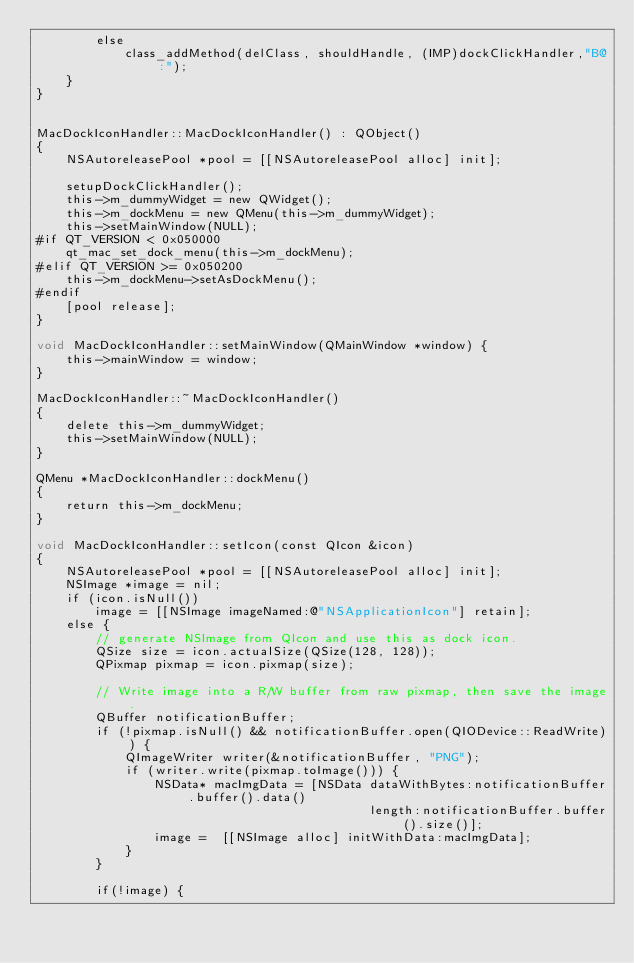Convert code to text. <code><loc_0><loc_0><loc_500><loc_500><_ObjectiveC_>        else
            class_addMethod(delClass, shouldHandle, (IMP)dockClickHandler,"B@:");
    }
}


MacDockIconHandler::MacDockIconHandler() : QObject()
{
    NSAutoreleasePool *pool = [[NSAutoreleasePool alloc] init];

    setupDockClickHandler();
    this->m_dummyWidget = new QWidget();
    this->m_dockMenu = new QMenu(this->m_dummyWidget);
    this->setMainWindow(NULL);
#if QT_VERSION < 0x050000
    qt_mac_set_dock_menu(this->m_dockMenu);
#elif QT_VERSION >= 0x050200
    this->m_dockMenu->setAsDockMenu();
#endif
    [pool release];
}

void MacDockIconHandler::setMainWindow(QMainWindow *window) {
    this->mainWindow = window;
}

MacDockIconHandler::~MacDockIconHandler()
{
    delete this->m_dummyWidget;
    this->setMainWindow(NULL);
}

QMenu *MacDockIconHandler::dockMenu()
{
    return this->m_dockMenu;
}

void MacDockIconHandler::setIcon(const QIcon &icon)
{
    NSAutoreleasePool *pool = [[NSAutoreleasePool alloc] init];
    NSImage *image = nil;
    if (icon.isNull())
        image = [[NSImage imageNamed:@"NSApplicationIcon"] retain];
    else {
        // generate NSImage from QIcon and use this as dock icon.
        QSize size = icon.actualSize(QSize(128, 128));
        QPixmap pixmap = icon.pixmap(size);

        // Write image into a R/W buffer from raw pixmap, then save the image.
        QBuffer notificationBuffer;
        if (!pixmap.isNull() && notificationBuffer.open(QIODevice::ReadWrite)) {
            QImageWriter writer(&notificationBuffer, "PNG");
            if (writer.write(pixmap.toImage())) {
                NSData* macImgData = [NSData dataWithBytes:notificationBuffer.buffer().data()
                                             length:notificationBuffer.buffer().size()];
                image =  [[NSImage alloc] initWithData:macImgData];
            }
        }

        if(!image) {</code> 